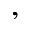<formula> <loc_0><loc_0><loc_500><loc_500>,</formula> 